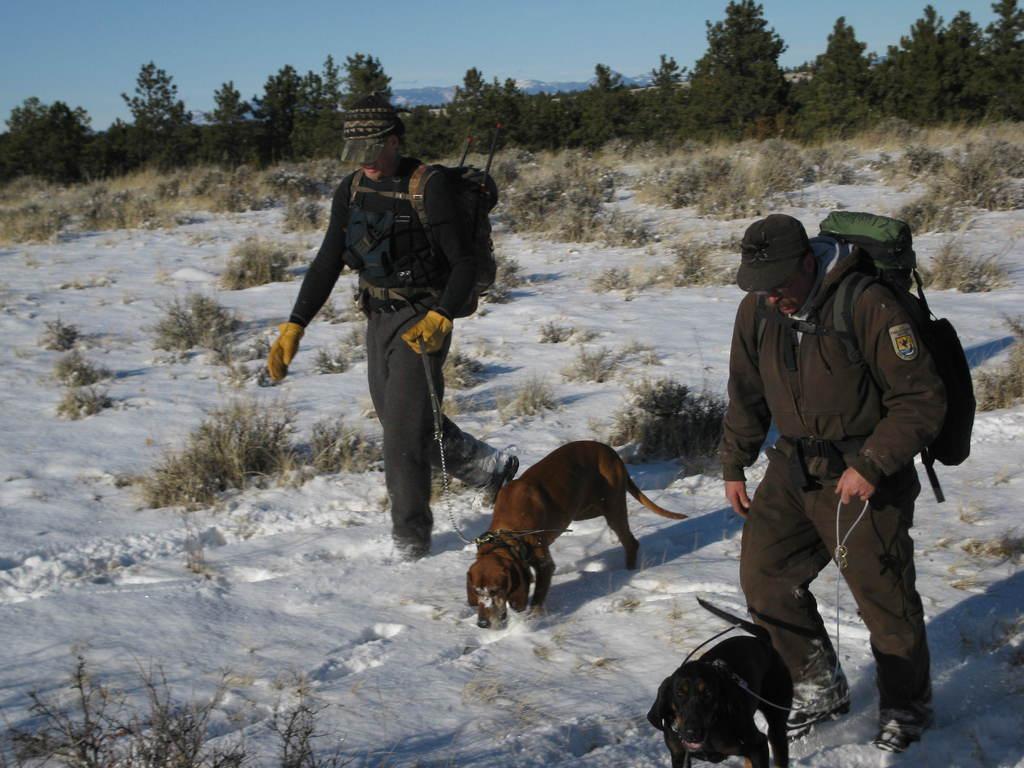Can you describe this image briefly? In the picture we can see a snow surface on it, we can see some parts of grass surface and two men are walking holding two dogs and they are in jackets, caps and wearing bags and in the background we can see trees and behind it we can see hills and sky. 